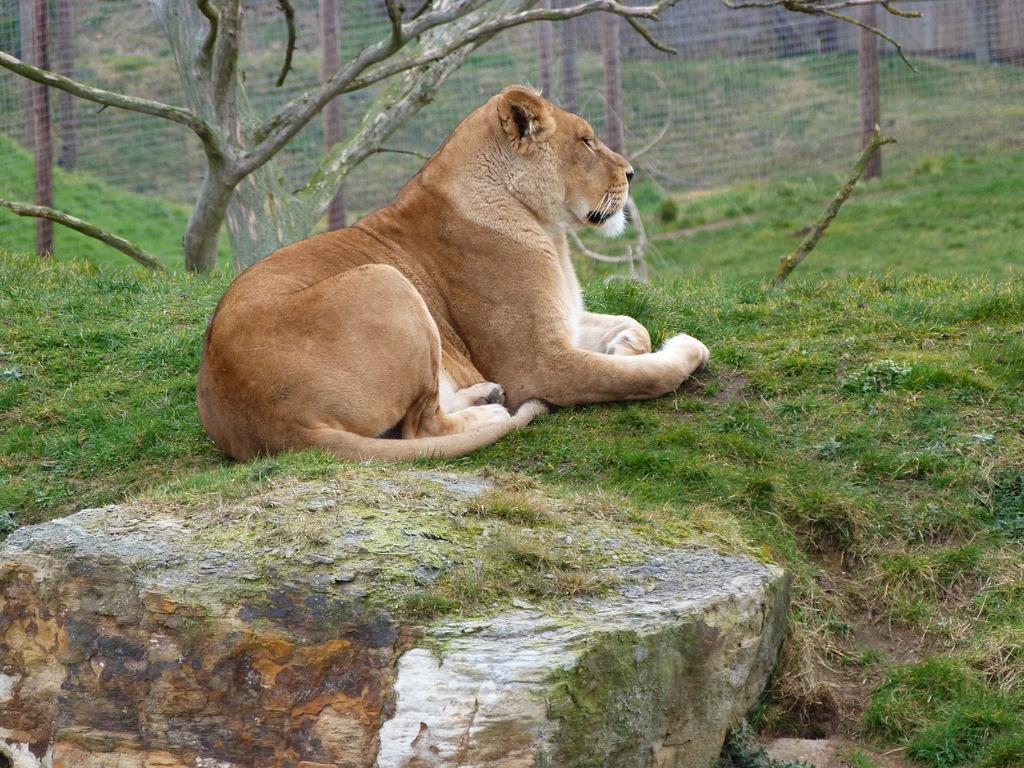Can you describe this image briefly? In the center of the image we can see one lion, which is in brown and white color. In the bottom of the image we can see the grass and stone. In the background we can see the fences, grass, one tree etc. 